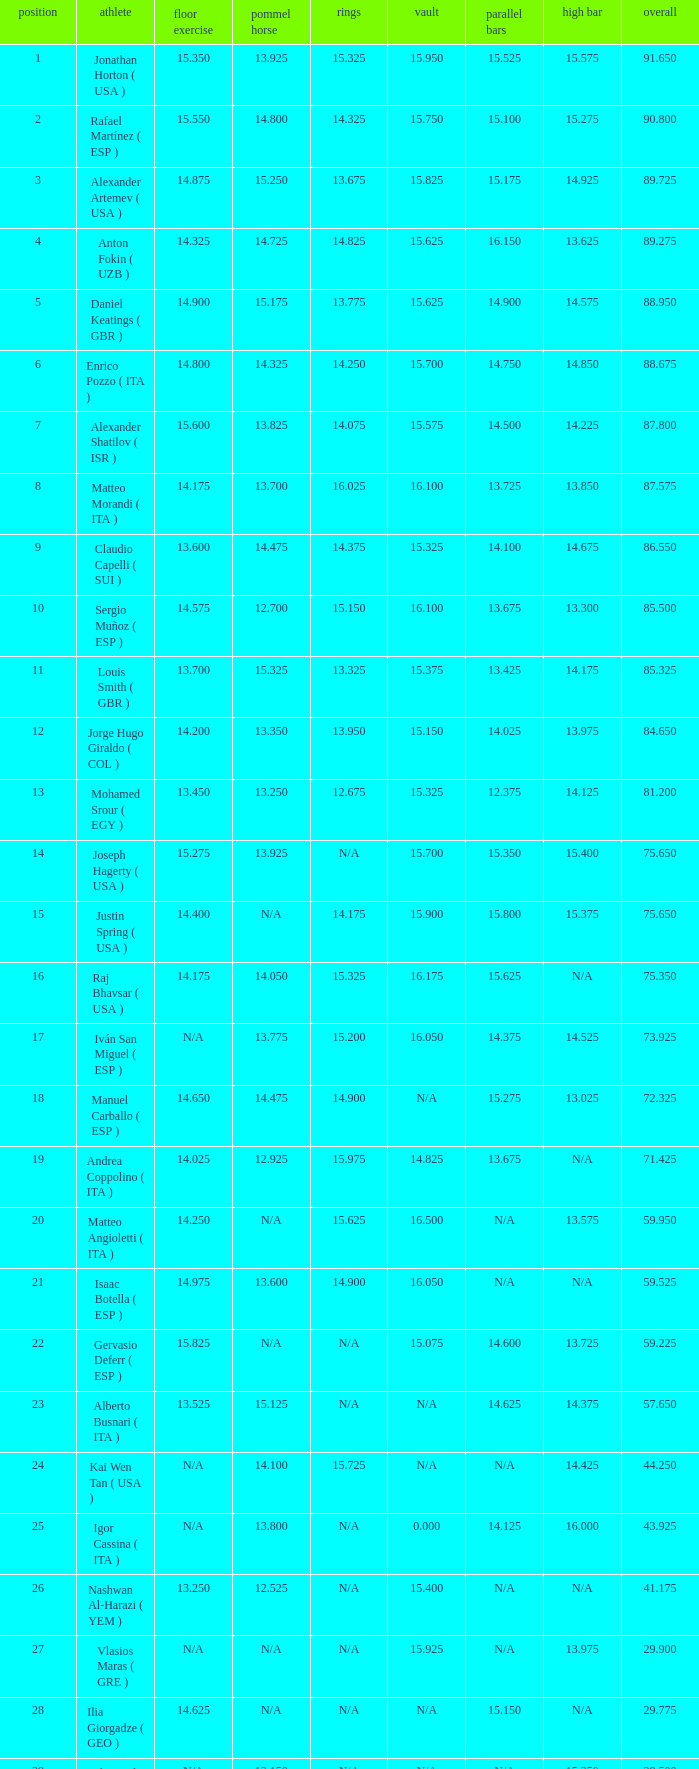I'm looking to parse the entire table for insights. Could you assist me with that? {'header': ['position', 'athlete', 'floor exercise', 'pommel horse', 'rings', 'vault', 'parallel bars', 'high bar', 'overall'], 'rows': [['1', 'Jonathan Horton ( USA )', '15.350', '13.925', '15.325', '15.950', '15.525', '15.575', '91.650'], ['2', 'Rafael Martínez ( ESP )', '15.550', '14.800', '14.325', '15.750', '15.100', '15.275', '90.800'], ['3', 'Alexander Artemev ( USA )', '14.875', '15.250', '13.675', '15.825', '15.175', '14.925', '89.725'], ['4', 'Anton Fokin ( UZB )', '14.325', '14.725', '14.825', '15.625', '16.150', '13.625', '89.275'], ['5', 'Daniel Keatings ( GBR )', '14.900', '15.175', '13.775', '15.625', '14.900', '14.575', '88.950'], ['6', 'Enrico Pozzo ( ITA )', '14.800', '14.325', '14.250', '15.700', '14.750', '14.850', '88.675'], ['7', 'Alexander Shatilov ( ISR )', '15.600', '13.825', '14.075', '15.575', '14.500', '14.225', '87.800'], ['8', 'Matteo Morandi ( ITA )', '14.175', '13.700', '16.025', '16.100', '13.725', '13.850', '87.575'], ['9', 'Claudio Capelli ( SUI )', '13.600', '14.475', '14.375', '15.325', '14.100', '14.675', '86.550'], ['10', 'Sergio Muñoz ( ESP )', '14.575', '12.700', '15.150', '16.100', '13.675', '13.300', '85.500'], ['11', 'Louis Smith ( GBR )', '13.700', '15.325', '13.325', '15.375', '13.425', '14.175', '85.325'], ['12', 'Jorge Hugo Giraldo ( COL )', '14.200', '13.350', '13.950', '15.150', '14.025', '13.975', '84.650'], ['13', 'Mohamed Srour ( EGY )', '13.450', '13.250', '12.675', '15.325', '12.375', '14.125', '81.200'], ['14', 'Joseph Hagerty ( USA )', '15.275', '13.925', 'N/A', '15.700', '15.350', '15.400', '75.650'], ['15', 'Justin Spring ( USA )', '14.400', 'N/A', '14.175', '15.900', '15.800', '15.375', '75.650'], ['16', 'Raj Bhavsar ( USA )', '14.175', '14.050', '15.325', '16.175', '15.625', 'N/A', '75.350'], ['17', 'Iván San Miguel ( ESP )', 'N/A', '13.775', '15.200', '16.050', '14.375', '14.525', '73.925'], ['18', 'Manuel Carballo ( ESP )', '14.650', '14.475', '14.900', 'N/A', '15.275', '13.025', '72.325'], ['19', 'Andrea Coppolino ( ITA )', '14.025', '12.925', '15.975', '14.825', '13.675', 'N/A', '71.425'], ['20', 'Matteo Angioletti ( ITA )', '14.250', 'N/A', '15.625', '16.500', 'N/A', '13.575', '59.950'], ['21', 'Isaac Botella ( ESP )', '14.975', '13.600', '14.900', '16.050', 'N/A', 'N/A', '59.525'], ['22', 'Gervasio Deferr ( ESP )', '15.825', 'N/A', 'N/A', '15.075', '14.600', '13.725', '59.225'], ['23', 'Alberto Busnari ( ITA )', '13.525', '15.125', 'N/A', 'N/A', '14.625', '14.375', '57.650'], ['24', 'Kai Wen Tan ( USA )', 'N/A', '14.100', '15.725', 'N/A', 'N/A', '14.425', '44.250'], ['25', 'Igor Cassina ( ITA )', 'N/A', '13.800', 'N/A', '0.000', '14.125', '16.000', '43.925'], ['26', 'Nashwan Al-Harazi ( YEM )', '13.250', '12.525', 'N/A', '15.400', 'N/A', 'N/A', '41.175'], ['27', 'Vlasios Maras ( GRE )', 'N/A', 'N/A', 'N/A', '15.925', 'N/A', '13.975', '29.900'], ['28', 'Ilia Giorgadze ( GEO )', '14.625', 'N/A', 'N/A', 'N/A', '15.150', 'N/A', '29.775'], ['29', 'Christoph Schärer ( SUI )', 'N/A', '13.150', 'N/A', 'N/A', 'N/A', '15.350', '28.500'], ['30', 'Leszek Blanik ( POL )', 'N/A', 'N/A', 'N/A', '16.700', 'N/A', 'N/A', '16.700']]} If the floor number is 14.200, what is the number for the parallel bars? 14.025. 